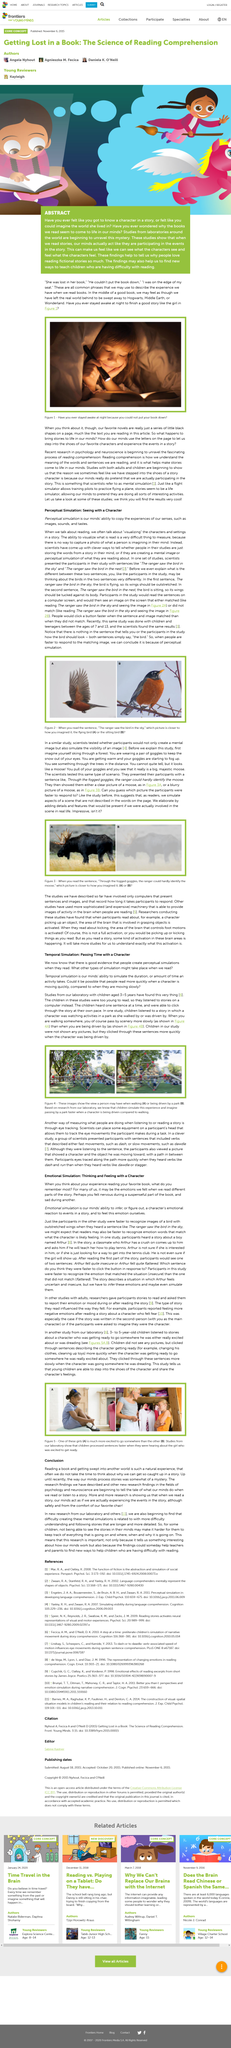Mention a couple of crucial points in this snapshot. When we read, we visualize the characters and settings in a story through the use of our imagination. This study was conducted on children aged 3-5, The title of this article is "temporal simulation: passing time with a character". It has been determined that studies involving both children and adults have been conducted. Reading comprehension is being studied in the fields of psychology and neuroscience, with the aim of gaining a deeper understanding of the cognitive processes involved in reading and comprehending text. 